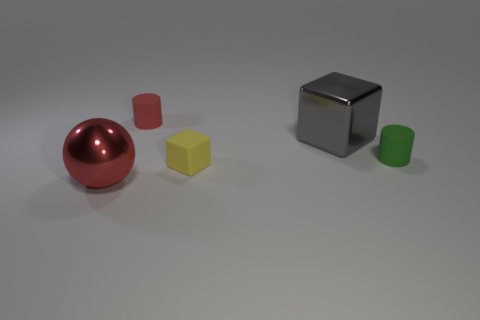Add 4 cyan rubber blocks. How many objects exist? 9 Subtract all yellow blocks. How many blocks are left? 1 Subtract all balls. How many objects are left? 4 Add 4 big things. How many big things are left? 6 Add 4 gray shiny cubes. How many gray shiny cubes exist? 5 Subtract 0 purple blocks. How many objects are left? 5 Subtract 1 spheres. How many spheres are left? 0 Subtract all cyan cylinders. Subtract all red spheres. How many cylinders are left? 2 Subtract all red matte things. Subtract all tiny green cylinders. How many objects are left? 3 